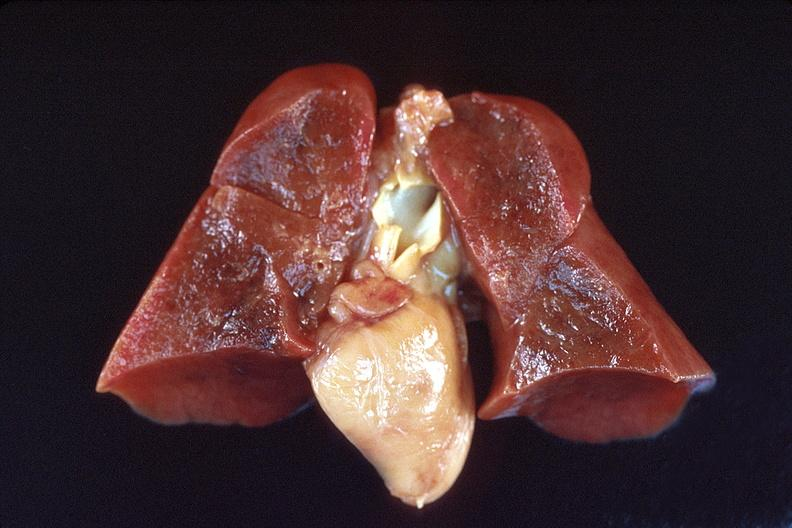s respiratory present?
Answer the question using a single word or phrase. Yes 